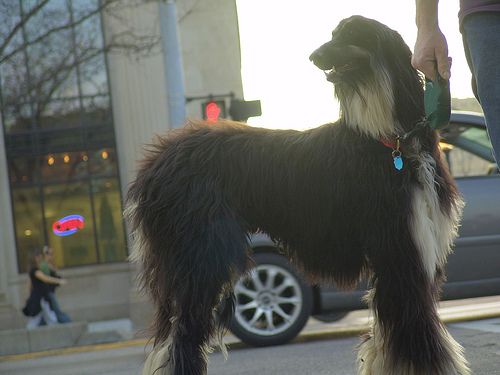<image>
Is the dog under the car? No. The dog is not positioned under the car. The vertical relationship between these objects is different. Is there a tire next to the woman? No. The tire is not positioned next to the woman. They are located in different areas of the scene. 